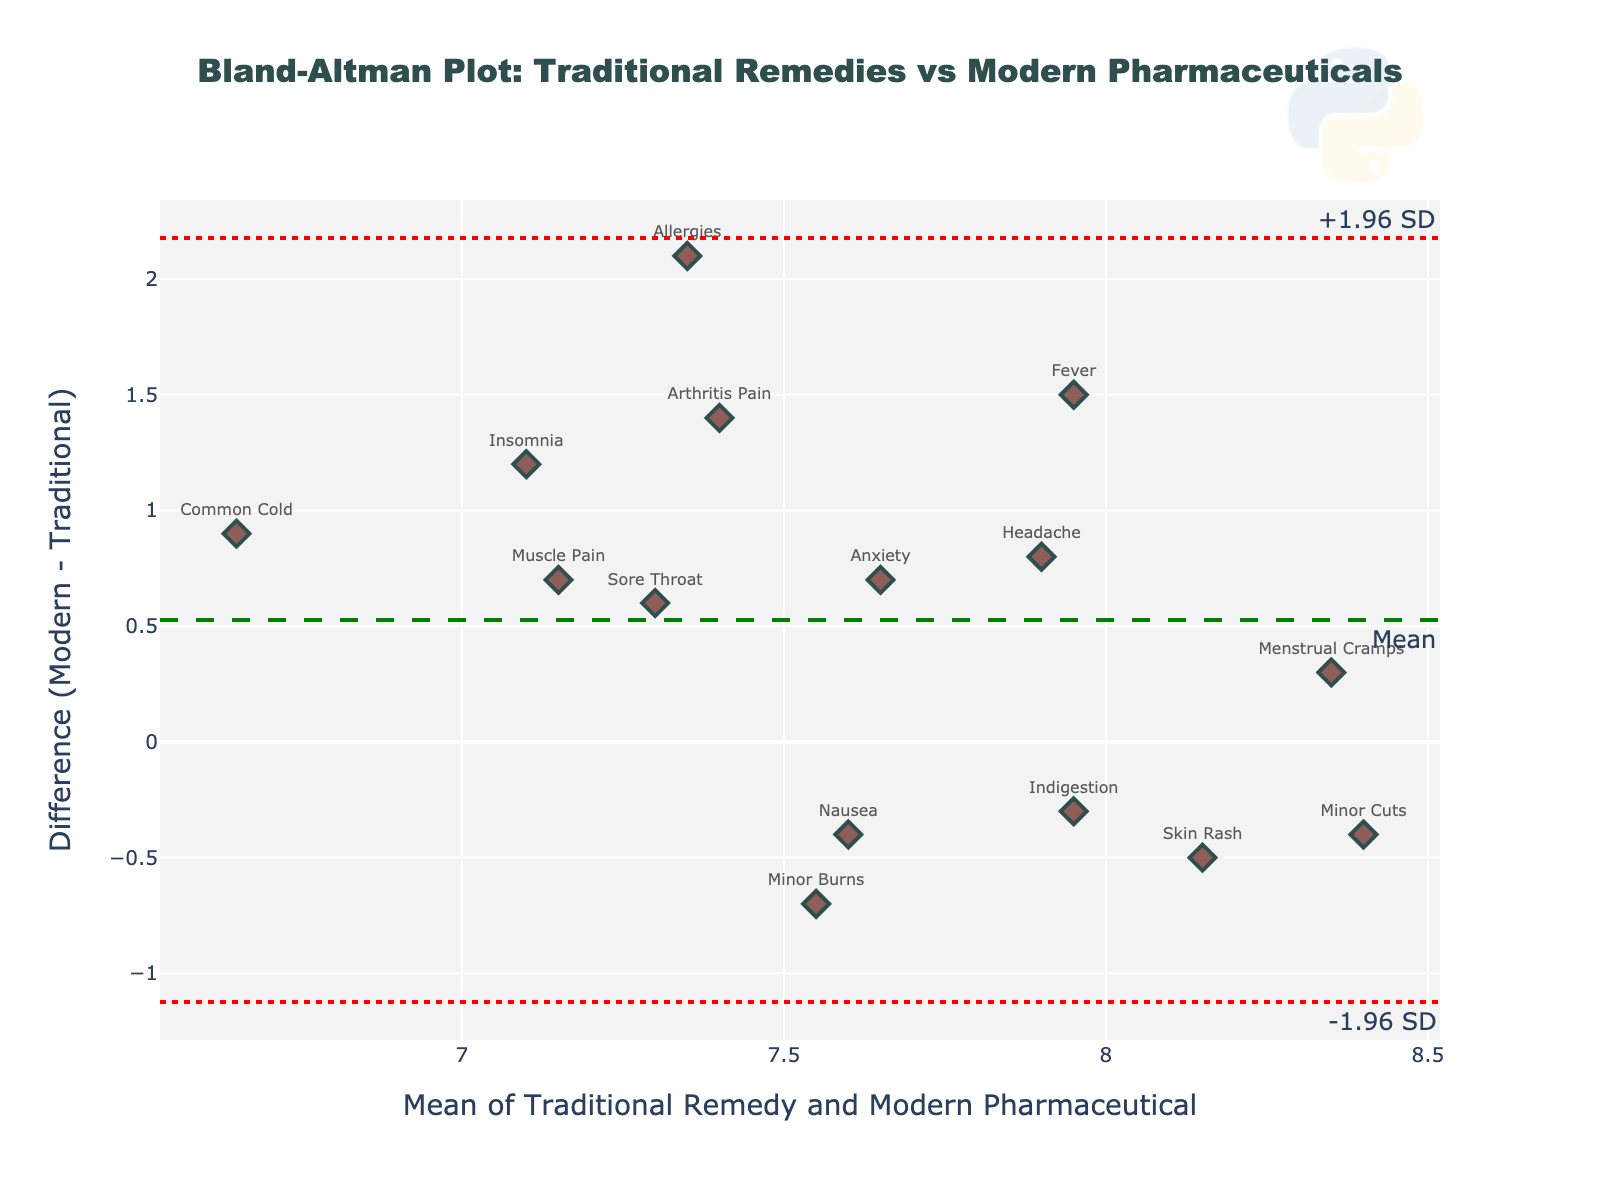How many treatments are compared in the plot? By counting the number of data points (markers) on the plot, we can determine the number of treatments compared. Each marker represents a treatment.
Answer: 15 What is the difference for the treatment "Fever"? Locate the treatment "Fever" on the plot by finding its label. The vertical position of the label will tell us the difference.
Answer: 1.5 Which treatment has the largest positive difference? Check the highest vertical point (positive difference) among the data points and identify the corresponding treatment label.
Answer: Allergies Which treatments have a negative difference? Identify all data points below the zero line (where the difference is negative) and note the corresponding treatment labels.
Answer: Indigestion, Minor Burns, Skin Rash, Nausea, Minor Cuts What is the mean difference of the plot? The mean difference line is indicated on the plot, usually represented by a dashed line. We can read the value from the plot legend or the axis.
Answer: 0.52 What is the upper limit of agreement? The upper limit of agreement is typically shown as a dotted line on the plot. The annotation or axis label near this line will indicate its value.
Answer: 2.02 Which treatments fall outside the limits of agreement? Observe the data points that lie outside the upper and lower dotted lines, which represent the limits of agreement, and note the corresponding treatment labels.
Answer: Allergies, Arthritis Pain Which treatment has a mean value closest to 8? Calculate the mean for each data point (average of Traditional Remedy and Modern Pharmaceutical values) and find the one closest to 8. The plot points can also guide us.
Answer: Menstrual Cramps, Minor Cuts How does the effectiveness of Traditional Remedy for "Insomnia" compare to Modern Pharmaceutical? Locate the treatment "Insomnia" on the plot and check its position relative to the zero line. The vertical placement shows if Traditional Remedy's effectiveness is lower or higher compared to Modern Pharmaceutical.
Answer: Lower What is the standard deviation of the differences? The gap between the mean difference and the upper/lower limits of agreement is typically 1.96 times the standard deviation. Rearrange the formula to find the standard deviation.
Answer: 0.765 